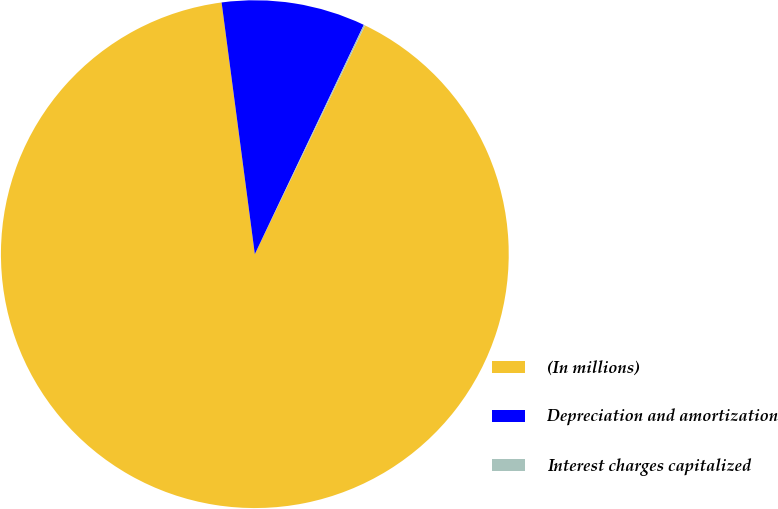<chart> <loc_0><loc_0><loc_500><loc_500><pie_chart><fcel>(In millions)<fcel>Depreciation and amortization<fcel>Interest charges capitalized<nl><fcel>90.76%<fcel>9.15%<fcel>0.09%<nl></chart> 